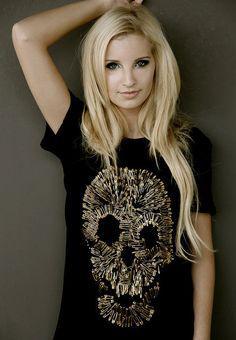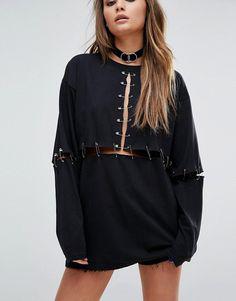The first image is the image on the left, the second image is the image on the right. For the images shown, is this caption "An image shows a model wearing a sleeveless black top embellished with safety pins spanning tears in the fabric." true? Answer yes or no. No. 